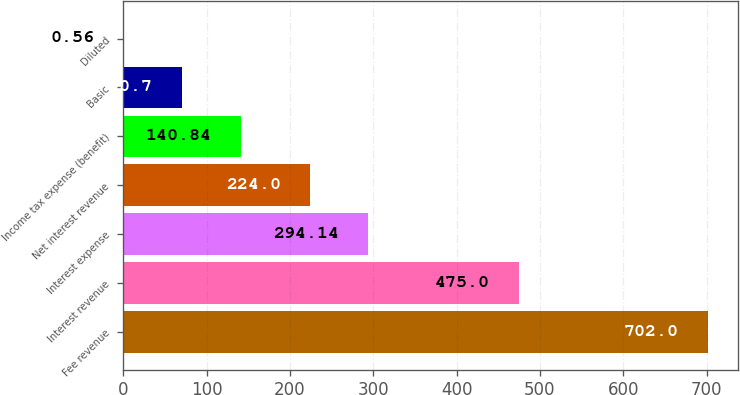<chart> <loc_0><loc_0><loc_500><loc_500><bar_chart><fcel>Fee revenue<fcel>Interest revenue<fcel>Interest expense<fcel>Net interest revenue<fcel>Income tax expense (benefit)<fcel>Basic<fcel>Diluted<nl><fcel>702<fcel>475<fcel>294.14<fcel>224<fcel>140.84<fcel>70.7<fcel>0.56<nl></chart> 